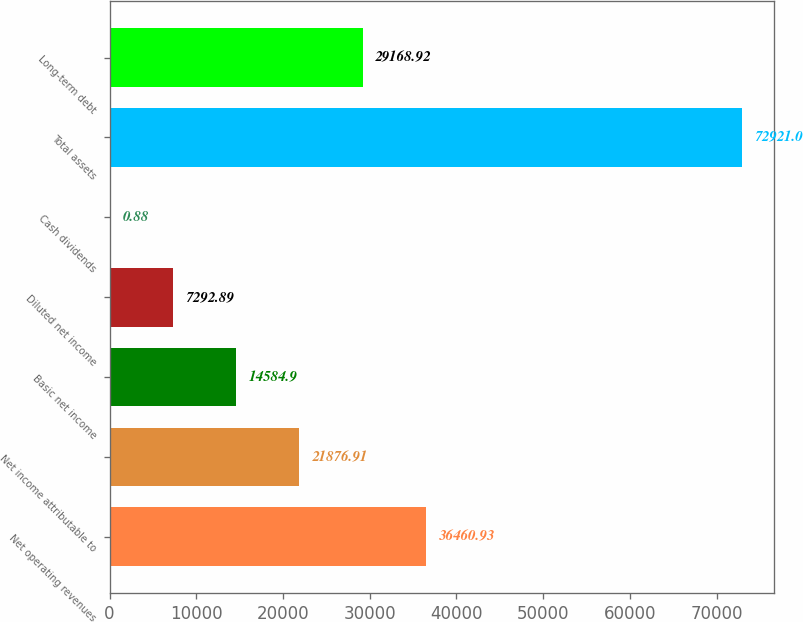<chart> <loc_0><loc_0><loc_500><loc_500><bar_chart><fcel>Net operating revenues<fcel>Net income attributable to<fcel>Basic net income<fcel>Diluted net income<fcel>Cash dividends<fcel>Total assets<fcel>Long-term debt<nl><fcel>36460.9<fcel>21876.9<fcel>14584.9<fcel>7292.89<fcel>0.88<fcel>72921<fcel>29168.9<nl></chart> 